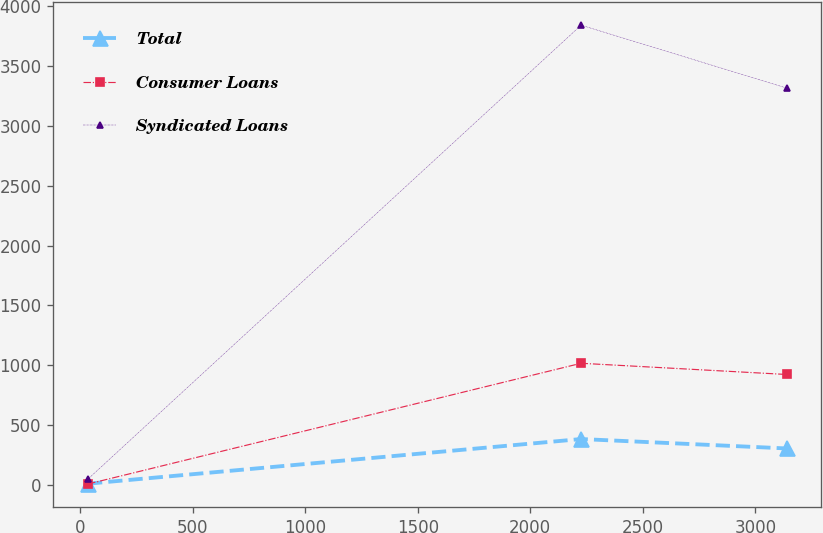Convert chart to OTSL. <chart><loc_0><loc_0><loc_500><loc_500><line_chart><ecel><fcel>Total<fcel>Consumer Loans<fcel>Syndicated Loans<nl><fcel>35.01<fcel>8.87<fcel>6.27<fcel>48.2<nl><fcel>2225.92<fcel>382.08<fcel>1015.48<fcel>3842.28<nl><fcel>3138.94<fcel>303.41<fcel>921.88<fcel>3316.62<nl></chart> 